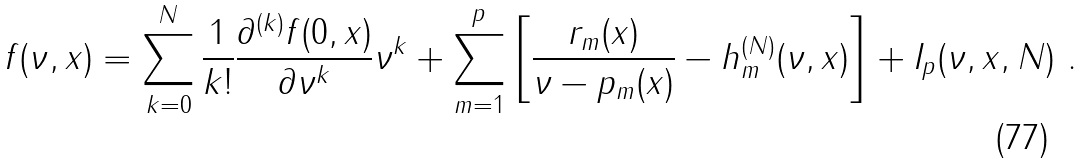Convert formula to latex. <formula><loc_0><loc_0><loc_500><loc_500>f ( \nu , x ) = \sum _ { k = 0 } ^ { N } \frac { 1 } { k ! } \frac { \partial ^ { ( k ) } f ( 0 , x ) } { \partial \nu ^ { k } } \nu ^ { k } + \sum _ { m = 1 } ^ { p } \left [ \frac { r _ { m } ( x ) } { \nu - p _ { m } ( x ) } - h _ { m } ^ { ( N ) } ( \nu , x ) \right ] + I _ { p } ( \nu , x , N ) \ .</formula> 